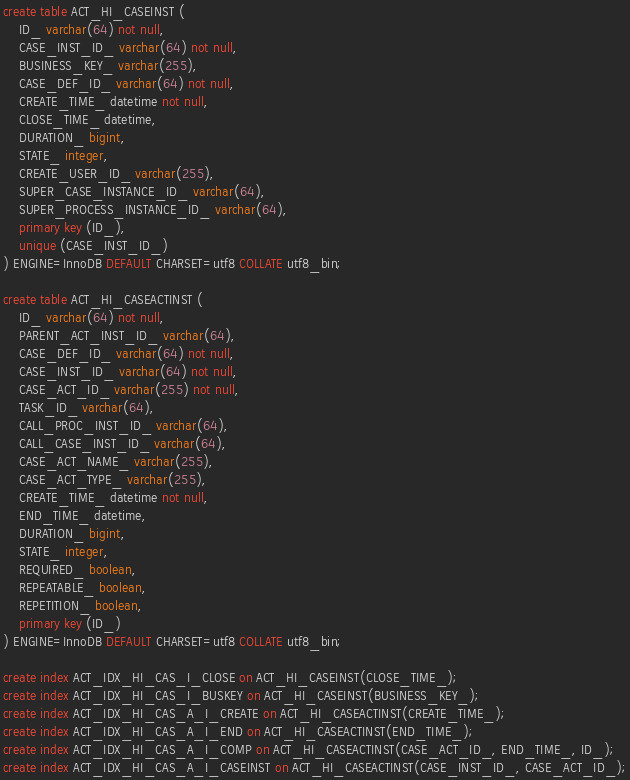Convert code to text. <code><loc_0><loc_0><loc_500><loc_500><_SQL_>create table ACT_HI_CASEINST (
    ID_ varchar(64) not null,
    CASE_INST_ID_ varchar(64) not null,
    BUSINESS_KEY_ varchar(255),
    CASE_DEF_ID_ varchar(64) not null,
    CREATE_TIME_ datetime not null,
    CLOSE_TIME_ datetime,
    DURATION_ bigint,
    STATE_ integer,
    CREATE_USER_ID_ varchar(255),
    SUPER_CASE_INSTANCE_ID_ varchar(64),
    SUPER_PROCESS_INSTANCE_ID_ varchar(64),
    primary key (ID_),
    unique (CASE_INST_ID_)
) ENGINE=InnoDB DEFAULT CHARSET=utf8 COLLATE utf8_bin;

create table ACT_HI_CASEACTINST (
    ID_ varchar(64) not null,
    PARENT_ACT_INST_ID_ varchar(64),
    CASE_DEF_ID_ varchar(64) not null,
    CASE_INST_ID_ varchar(64) not null,
    CASE_ACT_ID_ varchar(255) not null,
    TASK_ID_ varchar(64),
    CALL_PROC_INST_ID_ varchar(64),
    CALL_CASE_INST_ID_ varchar(64),
    CASE_ACT_NAME_ varchar(255),
    CASE_ACT_TYPE_ varchar(255),
    CREATE_TIME_ datetime not null,
    END_TIME_ datetime,
    DURATION_ bigint,
    STATE_ integer,
    REQUIRED_ boolean,
    REPEATABLE_ boolean,
    REPETITION_ boolean,
    primary key (ID_)
) ENGINE=InnoDB DEFAULT CHARSET=utf8 COLLATE utf8_bin;

create index ACT_IDX_HI_CAS_I_CLOSE on ACT_HI_CASEINST(CLOSE_TIME_);
create index ACT_IDX_HI_CAS_I_BUSKEY on ACT_HI_CASEINST(BUSINESS_KEY_);
create index ACT_IDX_HI_CAS_A_I_CREATE on ACT_HI_CASEACTINST(CREATE_TIME_);
create index ACT_IDX_HI_CAS_A_I_END on ACT_HI_CASEACTINST(END_TIME_);
create index ACT_IDX_HI_CAS_A_I_COMP on ACT_HI_CASEACTINST(CASE_ACT_ID_, END_TIME_, ID_);
create index ACT_IDX_HI_CAS_A_I_CASEINST on ACT_HI_CASEACTINST(CASE_INST_ID_, CASE_ACT_ID_);
</code> 